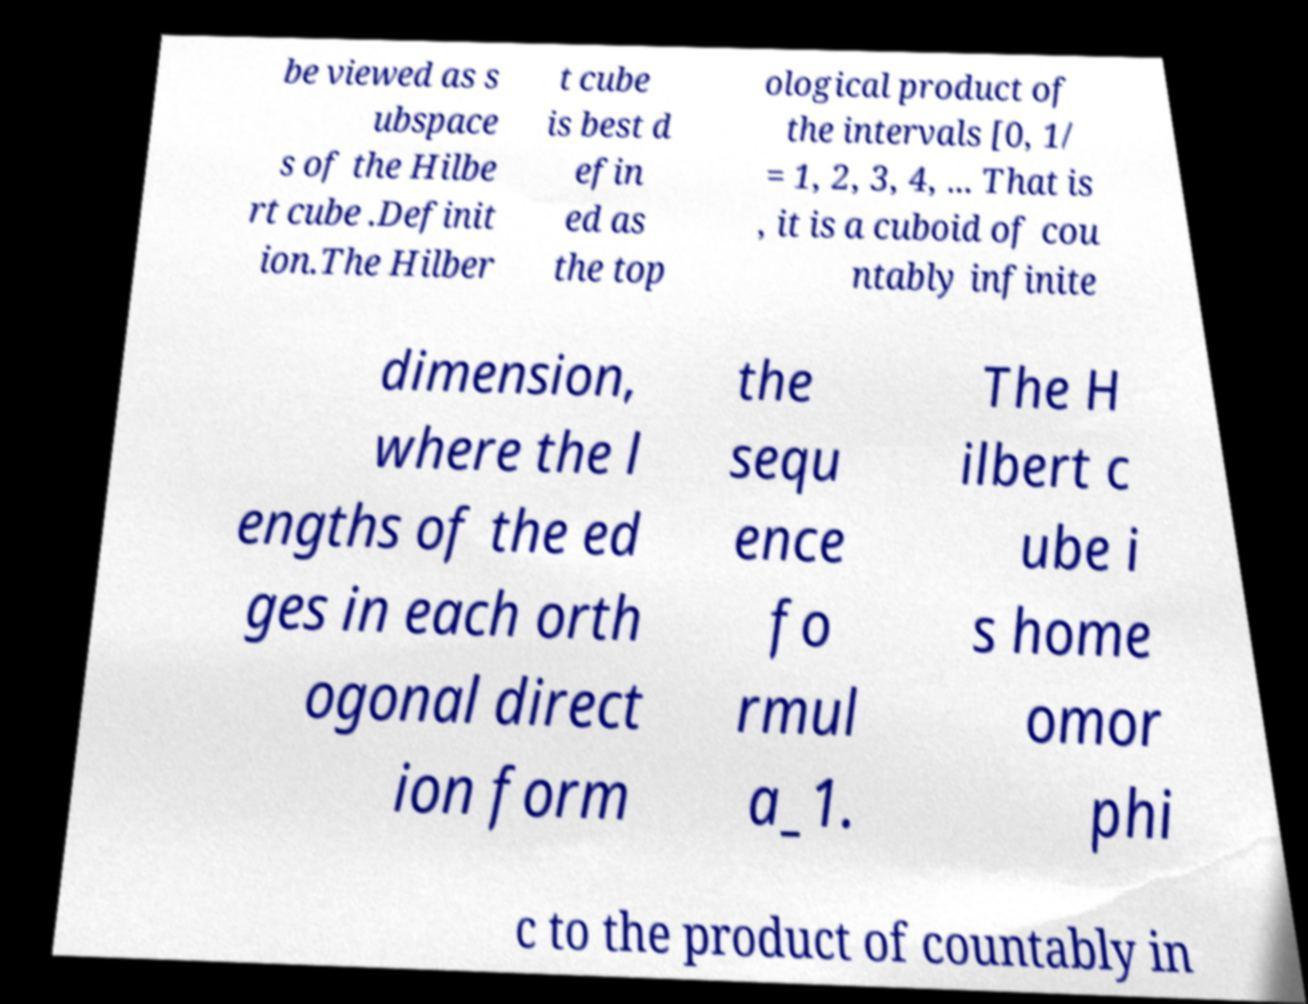What messages or text are displayed in this image? I need them in a readable, typed format. be viewed as s ubspace s of the Hilbe rt cube .Definit ion.The Hilber t cube is best d efin ed as the top ological product of the intervals [0, 1/ = 1, 2, 3, 4, ... That is , it is a cuboid of cou ntably infinite dimension, where the l engths of the ed ges in each orth ogonal direct ion form the sequ ence fo rmul a_1. The H ilbert c ube i s home omor phi c to the product of countably in 